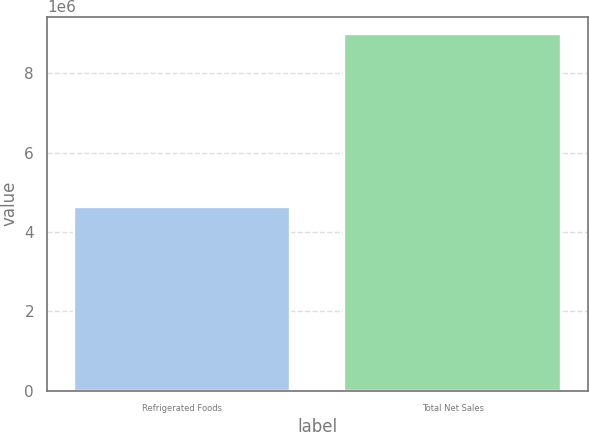Convert chart. <chart><loc_0><loc_0><loc_500><loc_500><bar_chart><fcel>Refrigerated Foods<fcel>Total Net Sales<nl><fcel>4.62392e+06<fcel>8.98484e+06<nl></chart> 